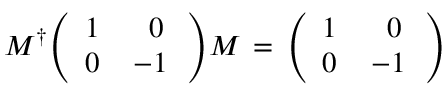Convert formula to latex. <formula><loc_0><loc_0><loc_500><loc_500>M ^ { \dagger } \left ( \begin{array} { c c } { 1 \, } & { \, 0 } \\ { 0 \, } & { - 1 \, } \end{array} \right ) M \, = \, \left ( \begin{array} { c c } { 1 \, } & { \, 0 } \\ { 0 \, } & { - 1 \, } \end{array} \right ) \,</formula> 